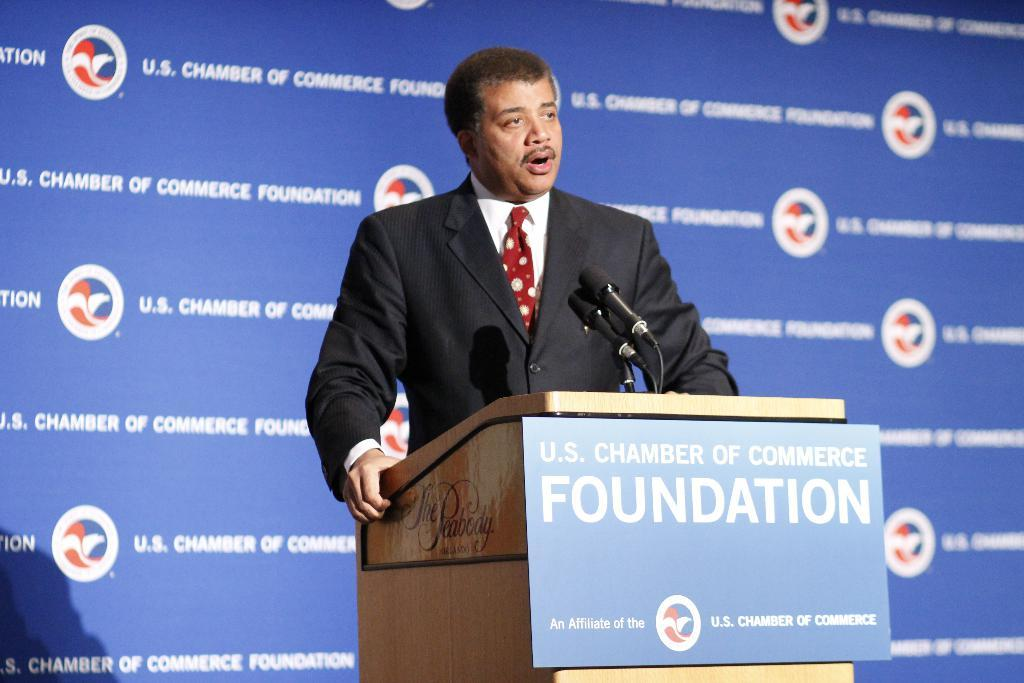What is the man in the image doing? The man is standing and talking. What can be seen on the podium in the image? Microphones are present on a podium. What is in front of the man? There is a board in front of the man. What is visible in the background of the image? There is a hoarding in the background. How many fingers does the man have on his left hand in the image? The image does not provide enough detail to determine the number of fingers on the man's left hand. 